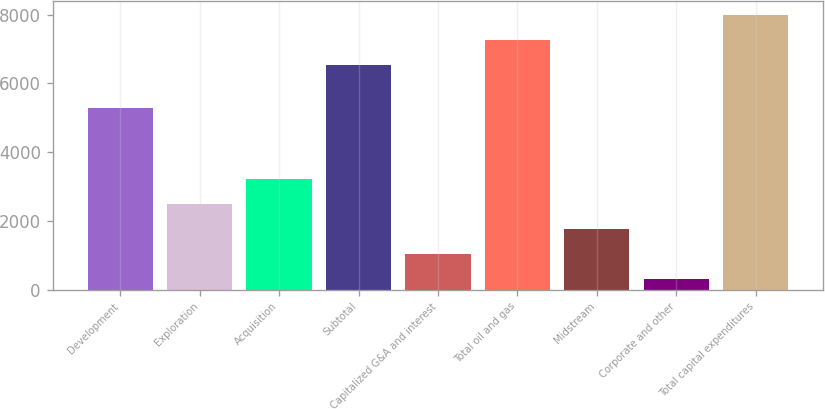Convert chart. <chart><loc_0><loc_0><loc_500><loc_500><bar_chart><fcel>Development<fcel>Exploration<fcel>Acquisition<fcel>Subtotal<fcel>Capitalized G&A and interest<fcel>Total oil and gas<fcel>Midstream<fcel>Corporate and other<fcel>Total capital expenditures<nl><fcel>5269<fcel>2484.9<fcel>3206.2<fcel>6548<fcel>1042.3<fcel>7269.3<fcel>1763.6<fcel>321<fcel>7990.6<nl></chart> 